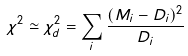Convert formula to latex. <formula><loc_0><loc_0><loc_500><loc_500>\chi ^ { 2 } \simeq \chi ^ { 2 } _ { d } = \sum _ { i } \frac { ( M _ { i } - D _ { i } ) ^ { 2 } } { D _ { i } }</formula> 